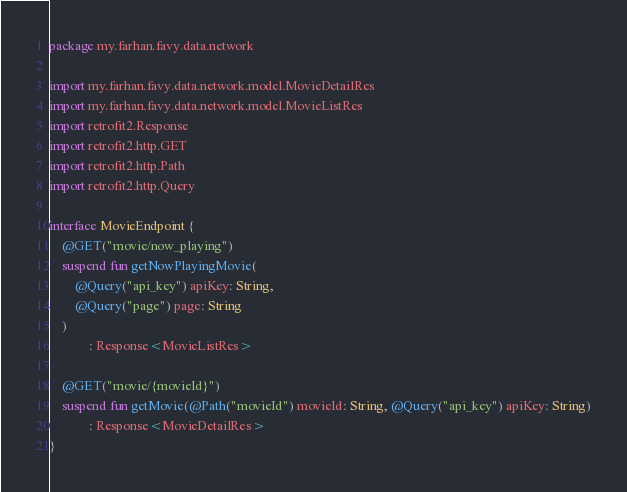<code> <loc_0><loc_0><loc_500><loc_500><_Kotlin_>package my.farhan.favy.data.network

import my.farhan.favy.data.network.model.MovieDetailRes
import my.farhan.favy.data.network.model.MovieListRes
import retrofit2.Response
import retrofit2.http.GET
import retrofit2.http.Path
import retrofit2.http.Query

interface MovieEndpoint {
    @GET("movie/now_playing")
    suspend fun getNowPlayingMovie(
        @Query("api_key") apiKey: String,
        @Query("page") page: String
    )
            : Response<MovieListRes>

    @GET("movie/{movieId}")
    suspend fun getMovie(@Path("movieId") movieId: String, @Query("api_key") apiKey: String)
            : Response<MovieDetailRes>
}</code> 